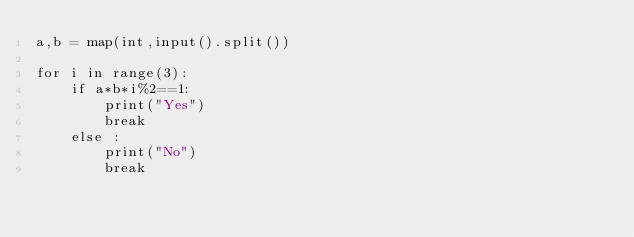Convert code to text. <code><loc_0><loc_0><loc_500><loc_500><_Python_>a,b = map(int,input().split())

for i in range(3):
    if a*b*i%2==1:
        print("Yes")
        break
    else :
        print("No")
        break</code> 